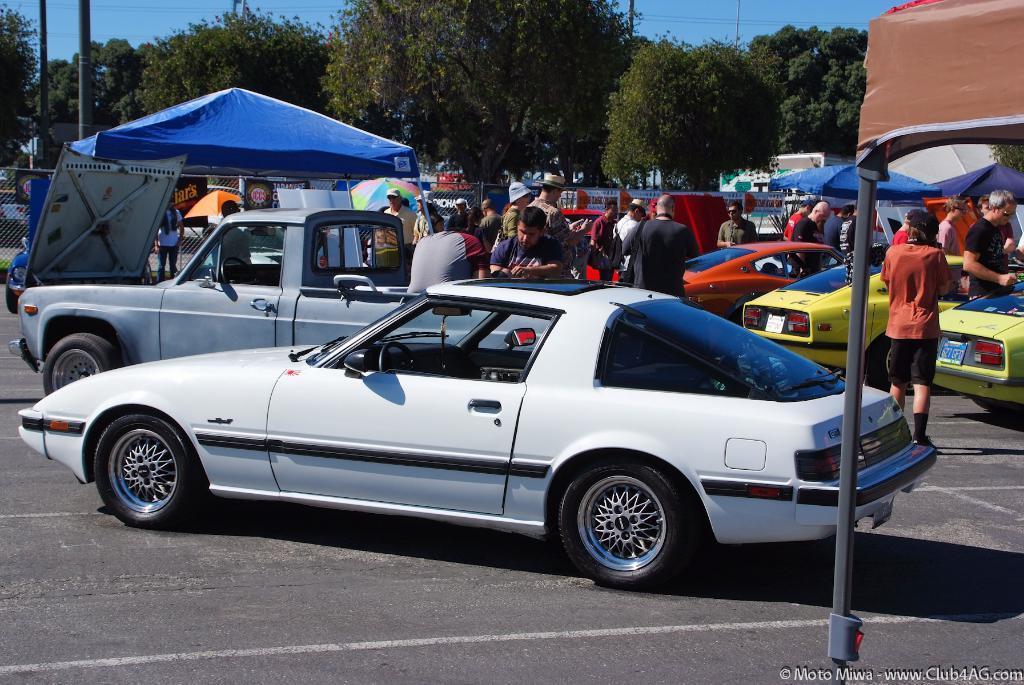Describe this image in one or two sentences. There are people and we can see vehicles on the road and we can see tents and fence. In the background we can see trees,poles and sky. 